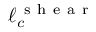Convert formula to latex. <formula><loc_0><loc_0><loc_500><loc_500>\ell _ { c } ^ { s h e a r }</formula> 